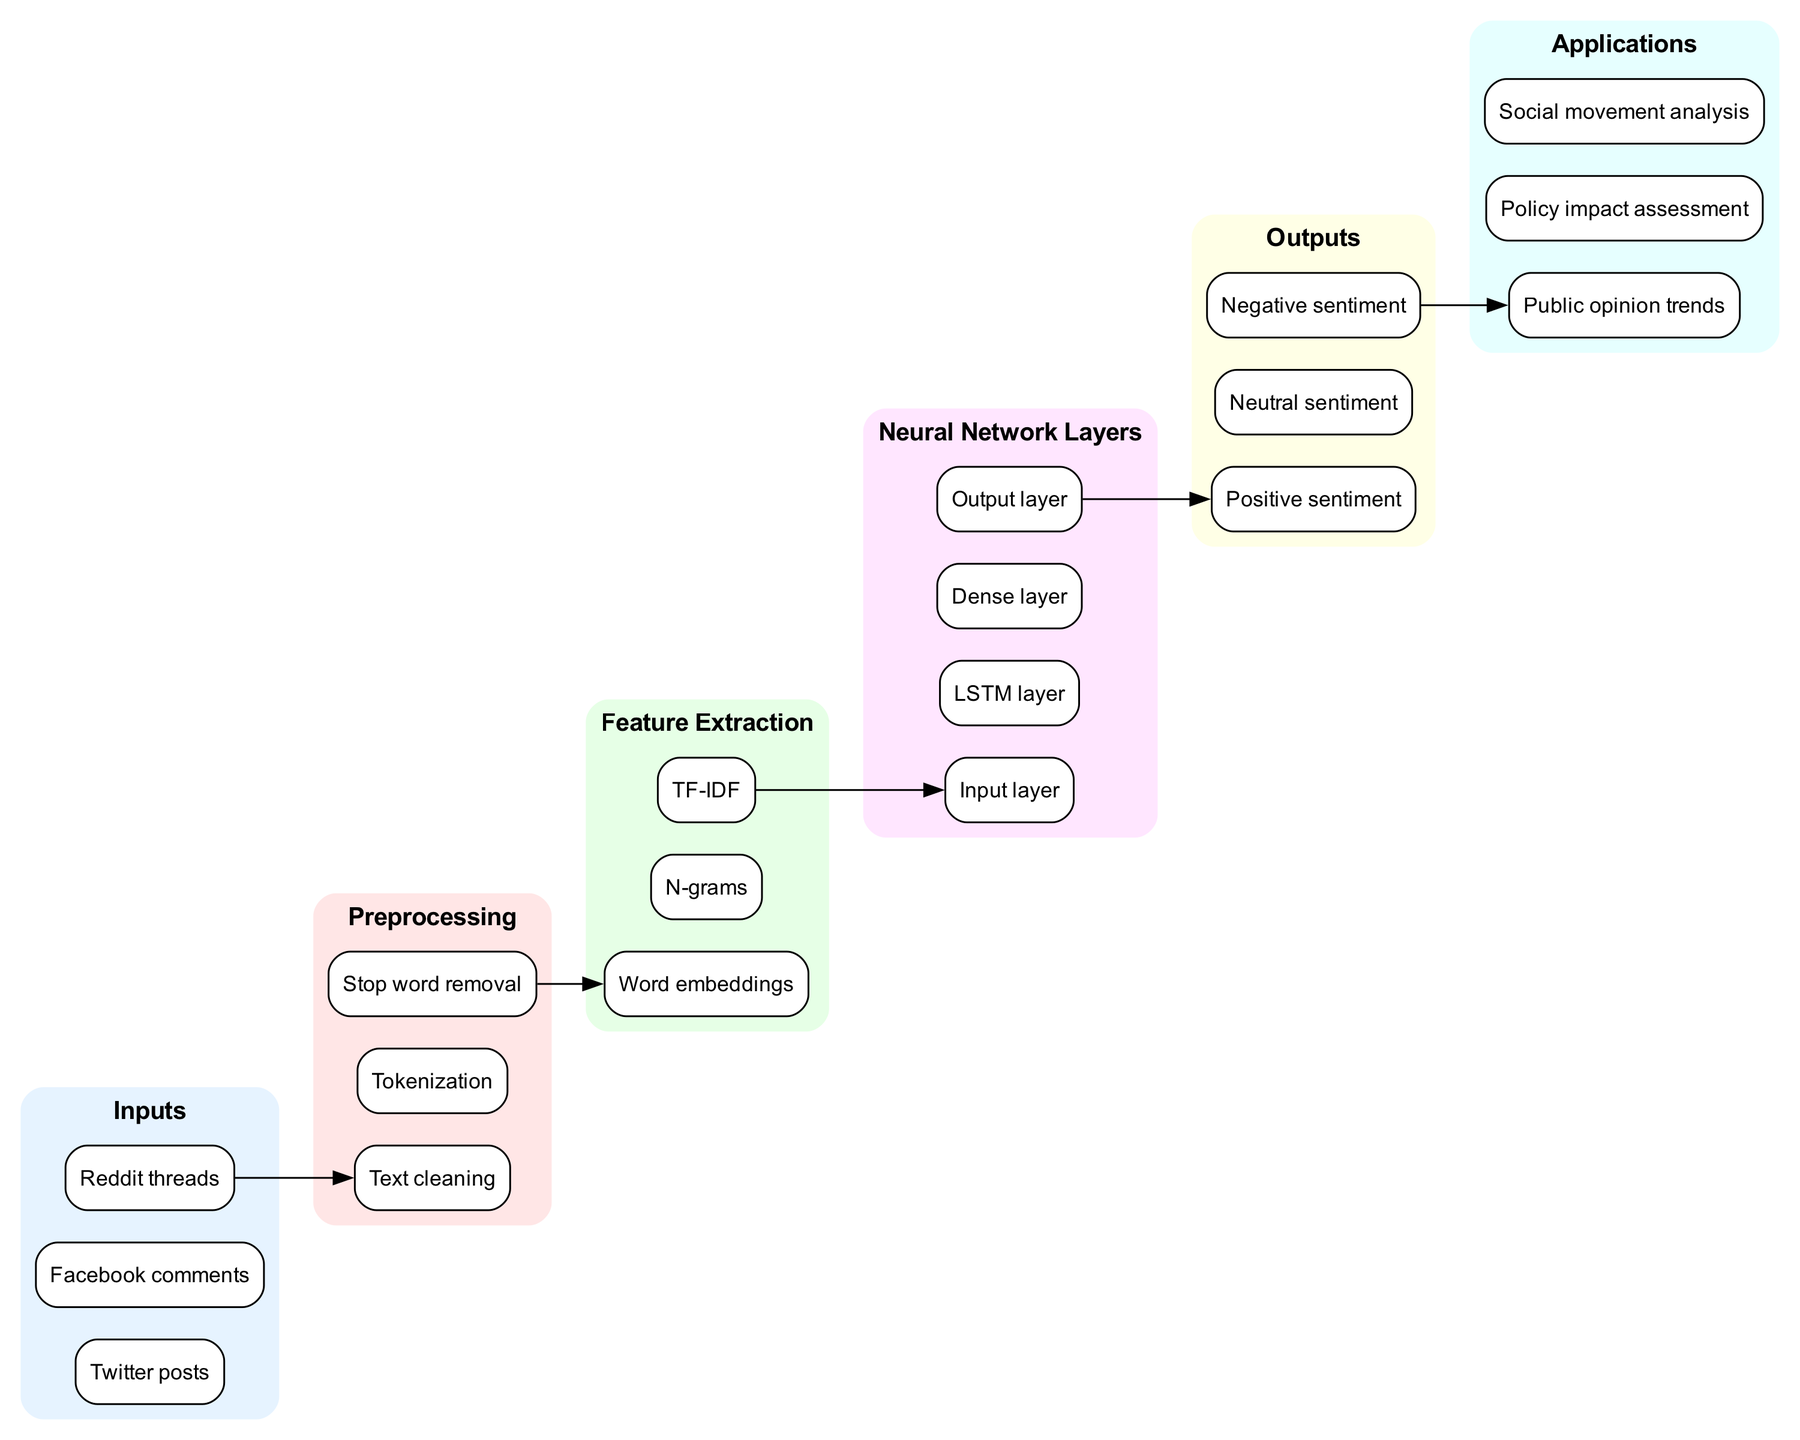What are the input types shown in the diagram? The diagram lists three categories of inputs which include Twitter posts, Facebook comments, and Reddit threads as the sources of data for sentiment analysis.
Answer: Twitter posts, Facebook comments, Reddit threads How many preprocessing steps are there? Upon reviewing the diagram, there are three distinct preprocessing steps mentioned: Text cleaning, Tokenization, and Stop word removal. Counting these gives a total of three steps.
Answer: 3 What is the first feature extraction method listed? In the feature extraction section of the diagram, the first method mentioned is Word embeddings, indicating it is prioritized over the others.
Answer: Word embeddings Which layer comes after the LSTM layer in the neural network? By following the layers of the neural network in the diagram, it is evident that the Dense layer is positioned directly after the LSTM layer, making it the subsequent layer.
Answer: Dense layer What are the outputs of the neural network? The diagram specifies three output sentiments, which are Positive sentiment, Neutral sentiment, and Negative sentiment, clearly outlining the possible categorizations of sentiment analysis.
Answer: Positive sentiment, Neutral sentiment, Negative sentiment What is the main application of the sentiment analysis shown towards public opinion? The diagram highlights various applications, and specifically mentions Public opinion trends as one of the primary uses of employing sentiment analysis in this context.
Answer: Public opinion trends What connects the Output layer to the Positive sentiment? The diagram shows a directed edge from the Output layer to the Positive sentiment, indicating that this connection signifies that the neural network uses its final output to determine whether the sentiment of the input is positive.
Answer: An edge Which preprocessing step directly precedes feature extraction? The diagram indicates that the Stop word removal is the last preprocessing step and directly leads to the feature extraction methods, emphasizing its role in preparing data for further analysis.
Answer: Stop word removal How many applications are described in the diagram? Upon inspecting the applications section of the diagram, three specific applications are identified: Public opinion trends, Policy impact assessment, and Social movement analysis, leading to a total count of three.
Answer: 3 